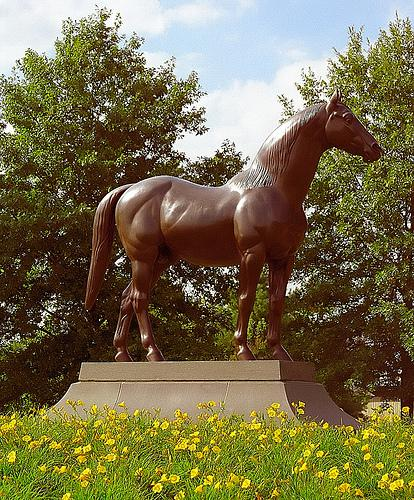Question: what color are the flowers?
Choices:
A. White.
B. Orange.
C. Yellow.
D. Green.
Answer with the letter. Answer: C Question: what type of statue is shown?
Choices:
A. Dog.
B. Horse.
C. Elephant.
D. Cow.
Answer with the letter. Answer: B Question: what color horse statue is shown?
Choices:
A. Grey.
B. Green.
C. Brown.
D. Black.
Answer with the letter. Answer: C Question: what is in the sky?
Choices:
A. The sun.
B. An airplane.
C. Clouds.
D. A ballon.
Answer with the letter. Answer: C Question: what color is the sky?
Choices:
A. White.
B. Grey.
C. Red-orange.
D. Blue.
Answer with the letter. Answer: D Question: what color are the trees?
Choices:
A. Brown.
B. Yellow.
C. Red.
D. Green.
Answer with the letter. Answer: D 